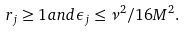Convert formula to latex. <formula><loc_0><loc_0><loc_500><loc_500>r _ { j } \geq 1 a n d \epsilon _ { j } \leq \nu ^ { 2 } / 1 6 M ^ { 2 } .</formula> 